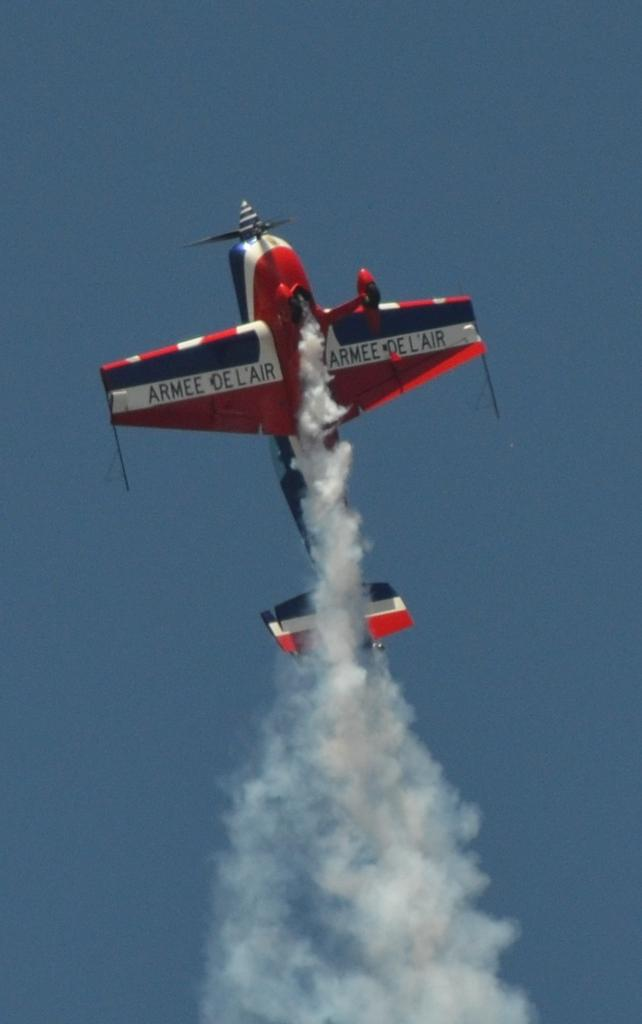What is the main subject of the image? The main subject of the image is an aircraft. Can you describe the position or state of the aircraft in the image? The aircraft is flying in the air. What is the name of the fight between the aircraft and the ground in the image? There is no fight depicted in the image, and therefore no such name can be given. What type of vessel is the aircraft in the image? The image does not show the aircraft as a part of any vessel; it is flying in the air. 